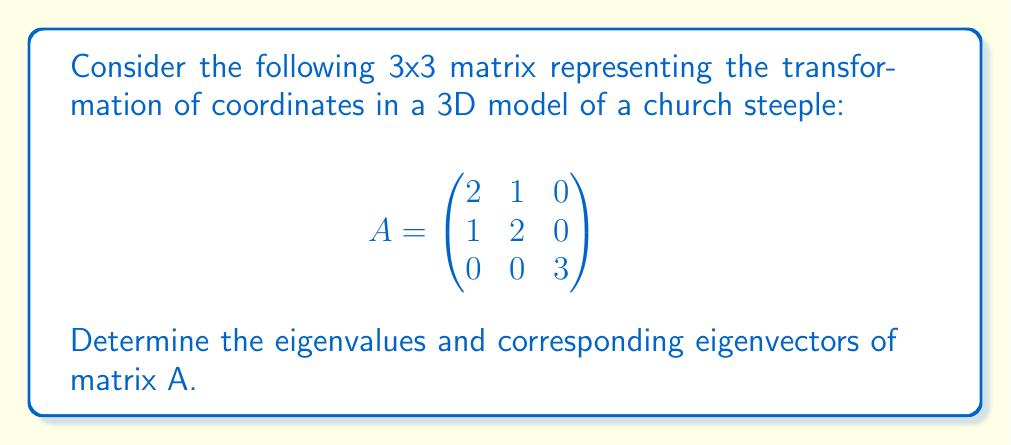Can you answer this question? To find the eigenvalues and eigenvectors, we'll follow these steps:

1) Find the characteristic equation:
   $det(A - \lambda I) = 0$

   $$\begin{vmatrix}
   2-\lambda & 1 & 0 \\
   1 & 2-\lambda & 0 \\
   0 & 0 & 3-\lambda
   \end{vmatrix} = 0$$

2) Expand the determinant:
   $((2-\lambda)(2-\lambda) - 1)(3-\lambda) = 0$
   $(4-4\lambda+\lambda^2 - 1)(3-\lambda) = 0$
   $(\lambda^2 - 4\lambda + 3)(3-\lambda) = 0$

3) Solve for $\lambda$:
   $(\lambda - 1)(\lambda - 3)(3-\lambda) = 0$
   $\lambda = 1, 3, 3$

4) Find eigenvectors for each eigenvalue:

   For $\lambda = 1$:
   $$(A - I)\mathbf{v} = \mathbf{0}$$
   $$\begin{pmatrix}
   1 & 1 & 0 \\
   1 & 1 & 0 \\
   0 & 0 & 2
   \end{pmatrix}\begin{pmatrix}
   v_1 \\ v_2 \\ v_3
   \end{pmatrix} = \begin{pmatrix}
   0 \\ 0 \\ 0
   \end{pmatrix}$$

   This gives: $v_1 = -v_2, v_3 = 0$
   Eigenvector: $\mathbf{v_1} = \begin{pmatrix} 1 \\ -1 \\ 0 \end{pmatrix}$

   For $\lambda = 3$ (multiplicity 2):
   $$(A - 3I)\mathbf{v} = \mathbf{0}$$
   $$\begin{pmatrix}
   -1 & 1 & 0 \\
   1 & -1 & 0 \\
   0 & 0 & 0
   \end{pmatrix}\begin{pmatrix}
   v_1 \\ v_2 \\ v_3
   \end{pmatrix} = \begin{pmatrix}
   0 \\ 0 \\ 0
   \end{pmatrix}$$

   This gives: $v_1 = v_2, v_3$ is free
   Eigenvectors: $\mathbf{v_2} = \begin{pmatrix} 1 \\ 1 \\ 0 \end{pmatrix}$, $\mathbf{v_3} = \begin{pmatrix} 0 \\ 0 \\ 1 \end{pmatrix}$
Answer: Eigenvalues: $\lambda_1 = 1$, $\lambda_2 = \lambda_3 = 3$
Eigenvectors: $\mathbf{v_1} = \begin{pmatrix} 1 \\ -1 \\ 0 \end{pmatrix}$, $\mathbf{v_2} = \begin{pmatrix} 1 \\ 1 \\ 0 \end{pmatrix}$, $\mathbf{v_3} = \begin{pmatrix} 0 \\ 0 \\ 1 \end{pmatrix}$ 